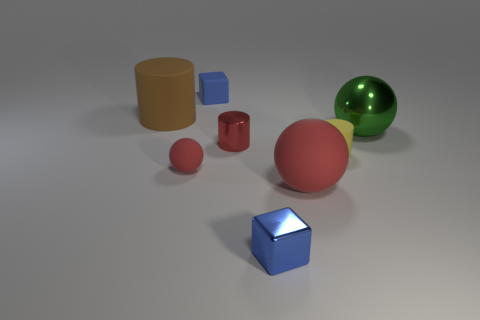The object that is both to the right of the tiny red ball and behind the big metal thing is what color?
Keep it short and to the point. Blue. What number of things are either brown rubber cylinders or purple balls?
Offer a terse response. 1. How many large objects are red metallic cylinders or shiny blocks?
Ensure brevity in your answer.  0. Is there any other thing that is the same color as the tiny sphere?
Give a very brief answer. Yes. What is the size of the matte object that is both behind the tiny red ball and to the right of the rubber cube?
Your answer should be compact. Small. Is the color of the large rubber object right of the blue metallic thing the same as the rubber cylinder on the left side of the large red thing?
Keep it short and to the point. No. How many other objects are there of the same material as the large brown object?
Your answer should be compact. 4. What is the shape of the large thing that is both behind the large rubber sphere and in front of the large brown cylinder?
Ensure brevity in your answer.  Sphere. Is the color of the large cylinder the same as the tiny block in front of the large green metallic thing?
Ensure brevity in your answer.  No. Does the blue cube behind the red cylinder have the same size as the brown cylinder?
Provide a short and direct response. No. 